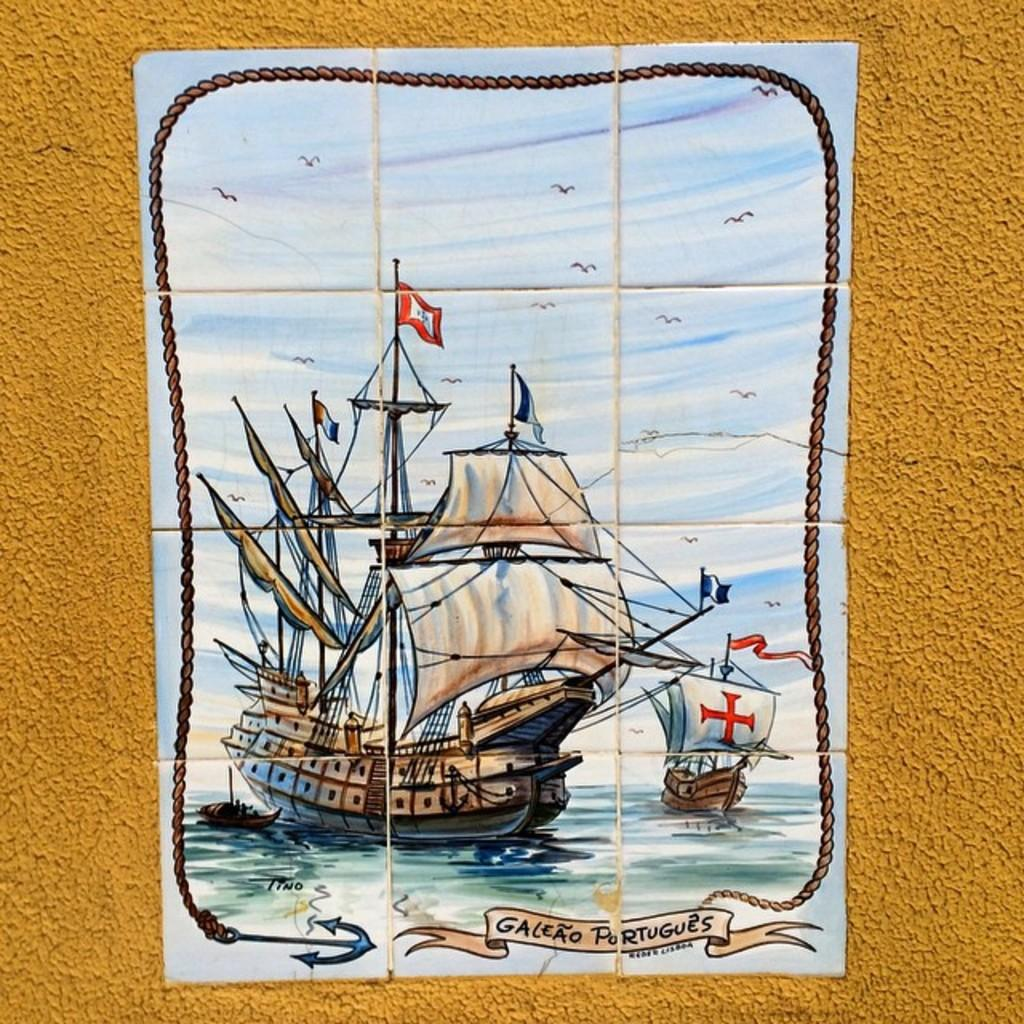<image>
Share a concise interpretation of the image provided. Poster showing a ship and the  words Galeao Portugues on the bottom. 